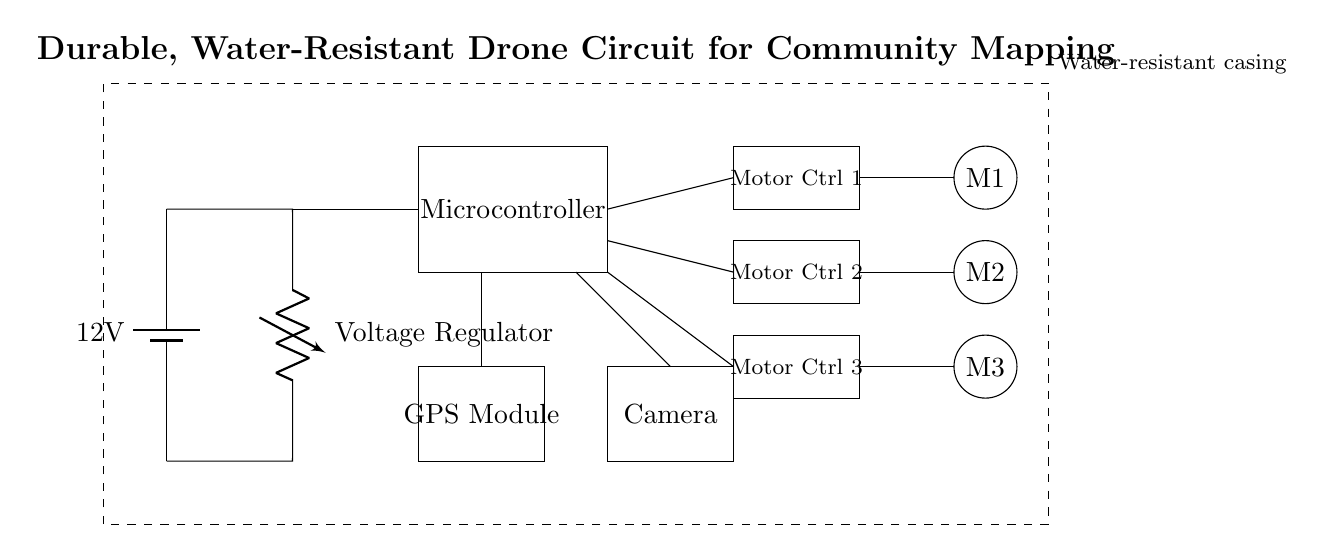What is the voltage of the battery in this circuit? The voltage is specified directly on the battery symbol in the diagram as twelve volts.
Answer: twelve volts How many motor controllers are shown in the diagram? The diagram clearly depicts three motor controllers labeled from one to three, each having a separate rectangle.
Answer: three What is the function of the GPS module in this circuit? The GPS module is included in the circuit to provide location data, essential for aerial community mapping tasks.
Answer: location data What type of casing protects the circuit? The circuit diagram shows a dashed rectangle, under the label "Water-resistant casing," indicating that the entire system is protected from water exposure.
Answer: water-resistant How many motors are included in this circuit? Upon examining the circles representing motors, there are three motors illustrated, each positioned below a motor controller.
Answer: three Which component is connected directly to the voltage regulator? The voltage regulator has a direct connection to the microcontroller, as indicated by the line between the two components in the diagram.
Answer: microcontroller What type of components are placed in the dashed rectangle? The dashed rectangle encompasses all the components to ensure they are shielded from water, designating the entire assembly as water-resistant.
Answer: circuit components 